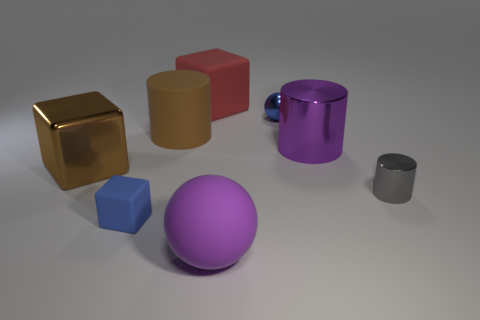Is there anything else that is the same color as the small metallic cylinder?
Keep it short and to the point. No. There is a big purple object that is made of the same material as the tiny gray object; what is its shape?
Provide a short and direct response. Cylinder. There is a metallic thing that is on the left side of the big block right of the blue cube; what number of blue things are behind it?
Ensure brevity in your answer.  1. There is a object that is behind the purple metallic cylinder and in front of the tiny blue ball; what shape is it?
Offer a very short reply. Cylinder. Is the number of small blue matte cubes that are behind the large purple cylinder less than the number of tiny blue metallic spheres?
Keep it short and to the point. Yes. What number of big objects are purple balls or brown shiny objects?
Provide a short and direct response. 2. The brown matte cylinder has what size?
Offer a very short reply. Large. Is there any other thing that is the same material as the blue cube?
Ensure brevity in your answer.  Yes. There is a tiny gray thing; what number of matte things are in front of it?
Your answer should be very brief. 2. What size is the purple thing that is the same shape as the blue metallic object?
Provide a succinct answer. Large. 